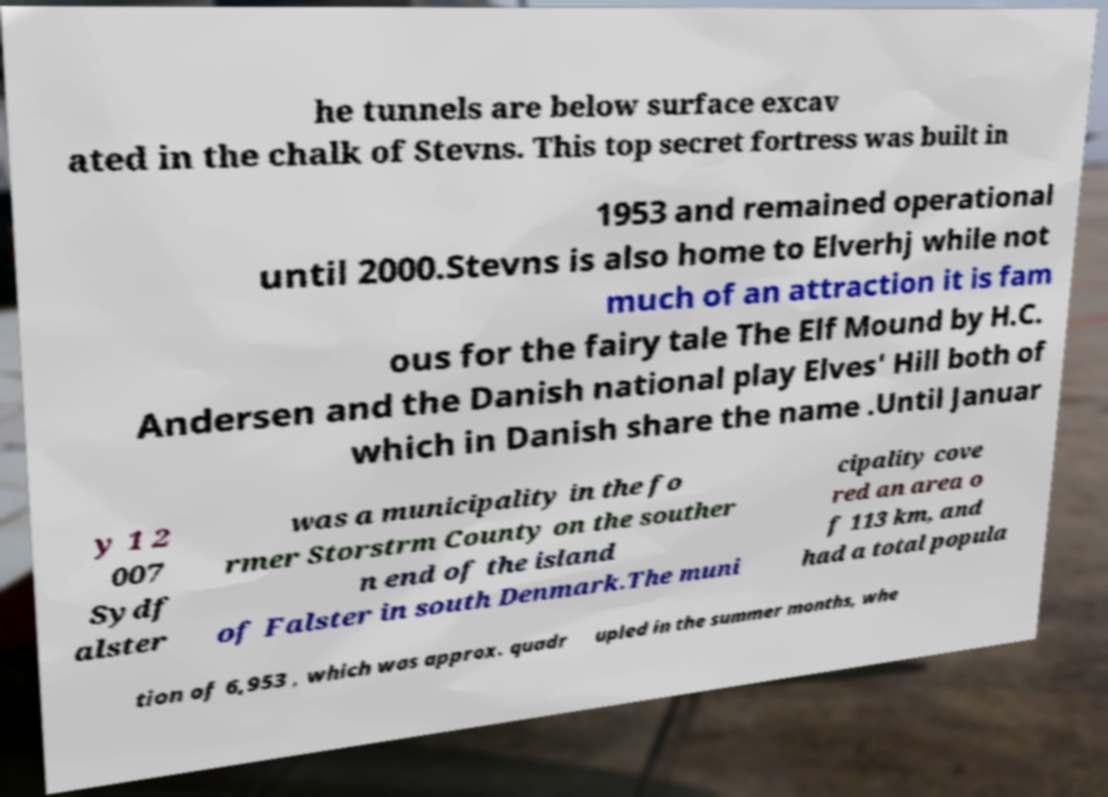What messages or text are displayed in this image? I need them in a readable, typed format. he tunnels are below surface excav ated in the chalk of Stevns. This top secret fortress was built in 1953 and remained operational until 2000.Stevns is also home to Elverhj while not much of an attraction it is fam ous for the fairy tale The Elf Mound by H.C. Andersen and the Danish national play Elves' Hill both of which in Danish share the name .Until Januar y 1 2 007 Sydf alster was a municipality in the fo rmer Storstrm County on the souther n end of the island of Falster in south Denmark.The muni cipality cove red an area o f 113 km, and had a total popula tion of 6,953 , which was approx. quadr upled in the summer months, whe 